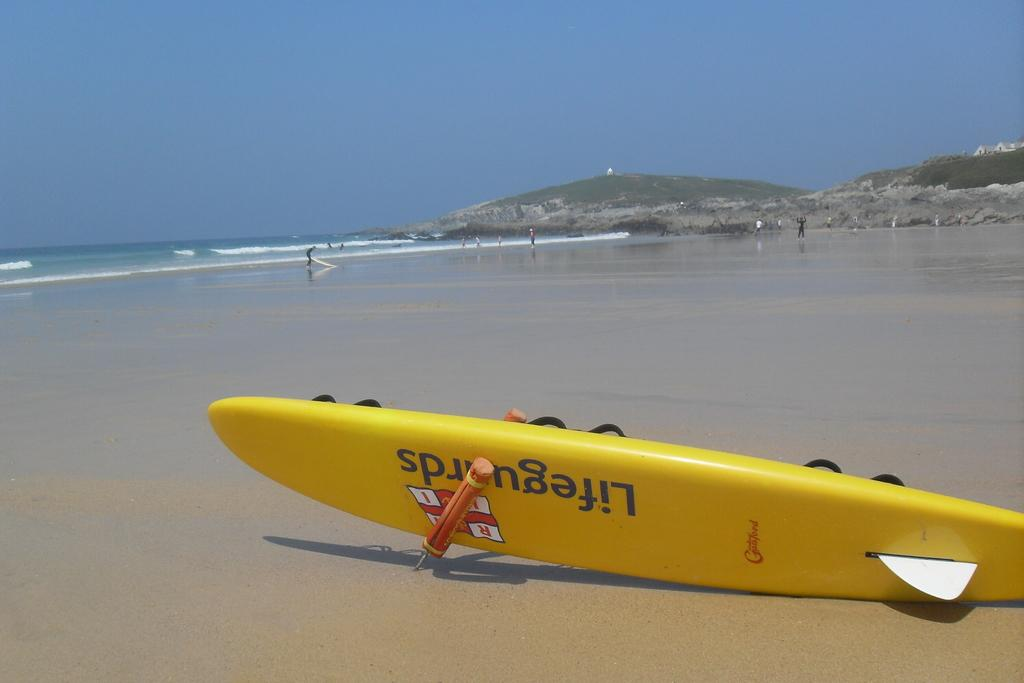<image>
Share a concise interpretation of the image provided. the word lifeguards that is in a boat 